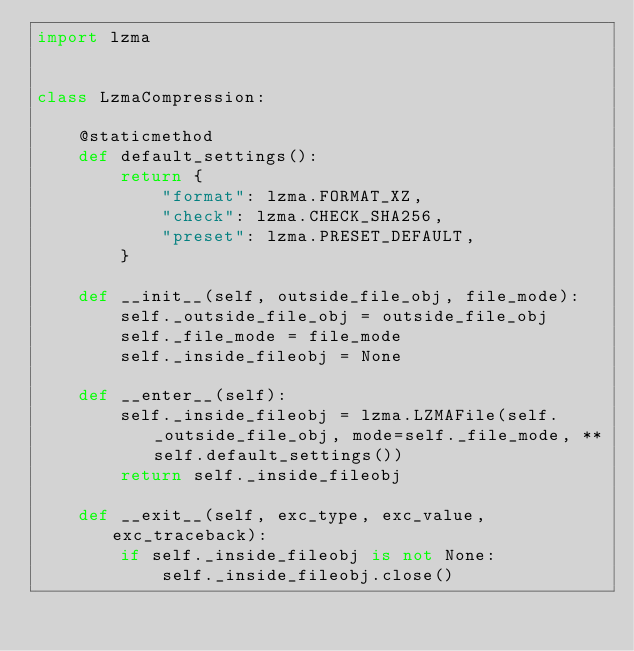<code> <loc_0><loc_0><loc_500><loc_500><_Python_>import lzma


class LzmaCompression:

    @staticmethod
    def default_settings():
        return {
            "format": lzma.FORMAT_XZ,
            "check": lzma.CHECK_SHA256,
            "preset": lzma.PRESET_DEFAULT,
        }

    def __init__(self, outside_file_obj, file_mode):
        self._outside_file_obj = outside_file_obj
        self._file_mode = file_mode
        self._inside_fileobj = None

    def __enter__(self):
        self._inside_fileobj = lzma.LZMAFile(self._outside_file_obj, mode=self._file_mode, **self.default_settings())
        return self._inside_fileobj

    def __exit__(self, exc_type, exc_value, exc_traceback):
        if self._inside_fileobj is not None:
            self._inside_fileobj.close()
</code> 